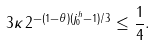<formula> <loc_0><loc_0><loc_500><loc_500>3 \kappa \, 2 ^ { - ( 1 - \theta ) ( j ^ { h } _ { 0 } - 1 ) / 3 } \leq \frac { 1 } { 4 } .</formula> 